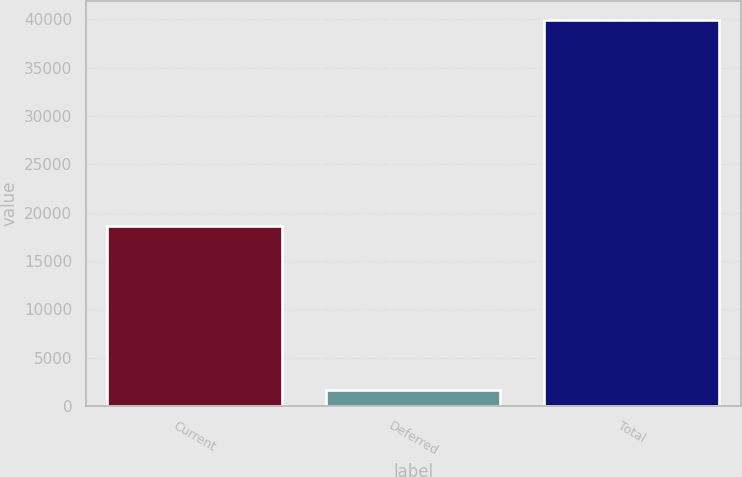<chart> <loc_0><loc_0><loc_500><loc_500><bar_chart><fcel>Current<fcel>Deferred<fcel>Total<nl><fcel>18576<fcel>1639<fcel>39937<nl></chart> 